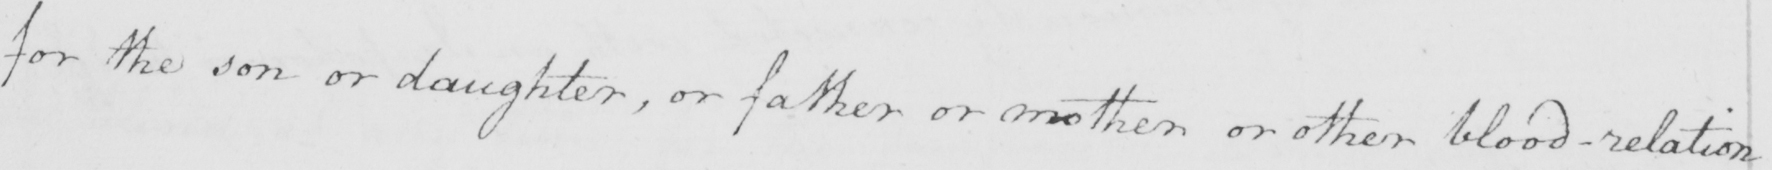What is written in this line of handwriting? for the son or daughter , or father or mother or other blood-relation 